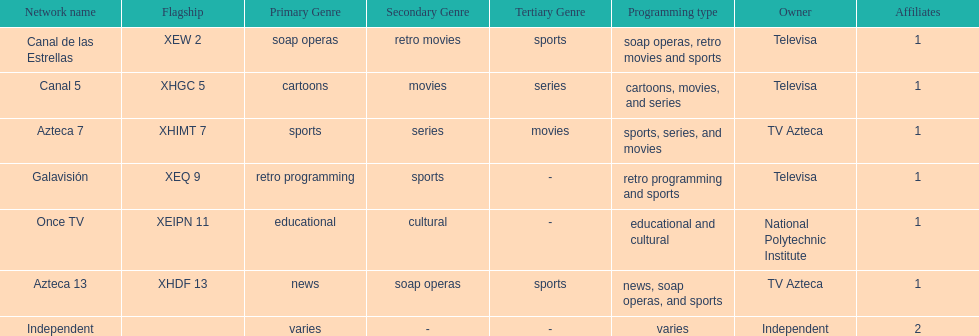Who is the only network possessor featured in a consecutive sequence in the chart? Televisa. 